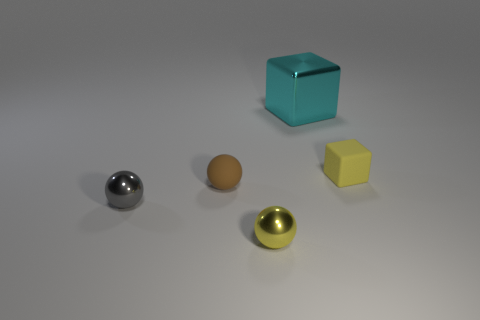Subtract all shiny balls. How many balls are left? 1 Add 1 tiny yellow metal objects. How many objects exist? 6 Subtract all spheres. How many objects are left? 2 Subtract all cyan spheres. Subtract all blue cylinders. How many spheres are left? 3 Subtract 0 purple cubes. How many objects are left? 5 Subtract all small brown rubber spheres. Subtract all yellow metallic cylinders. How many objects are left? 4 Add 3 tiny matte blocks. How many tiny matte blocks are left? 4 Add 3 small brown blocks. How many small brown blocks exist? 3 